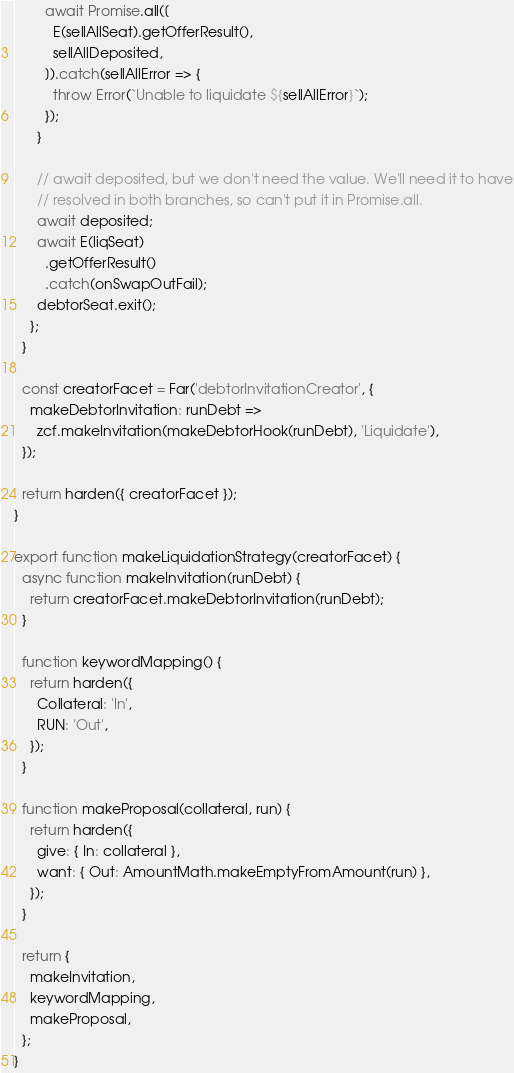Convert code to text. <code><loc_0><loc_0><loc_500><loc_500><_JavaScript_>        await Promise.all([
          E(sellAllSeat).getOfferResult(),
          sellAllDeposited,
        ]).catch(sellAllError => {
          throw Error(`Unable to liquidate ${sellAllError}`);
        });
      }

      // await deposited, but we don't need the value. We'll need it to have
      // resolved in both branches, so can't put it in Promise.all.
      await deposited;
      await E(liqSeat)
        .getOfferResult()
        .catch(onSwapOutFail);
      debtorSeat.exit();
    };
  }

  const creatorFacet = Far('debtorInvitationCreator', {
    makeDebtorInvitation: runDebt =>
      zcf.makeInvitation(makeDebtorHook(runDebt), 'Liquidate'),
  });

  return harden({ creatorFacet });
}

export function makeLiquidationStrategy(creatorFacet) {
  async function makeInvitation(runDebt) {
    return creatorFacet.makeDebtorInvitation(runDebt);
  }

  function keywordMapping() {
    return harden({
      Collateral: 'In',
      RUN: 'Out',
    });
  }

  function makeProposal(collateral, run) {
    return harden({
      give: { In: collateral },
      want: { Out: AmountMath.makeEmptyFromAmount(run) },
    });
  }

  return {
    makeInvitation,
    keywordMapping,
    makeProposal,
  };
}
</code> 